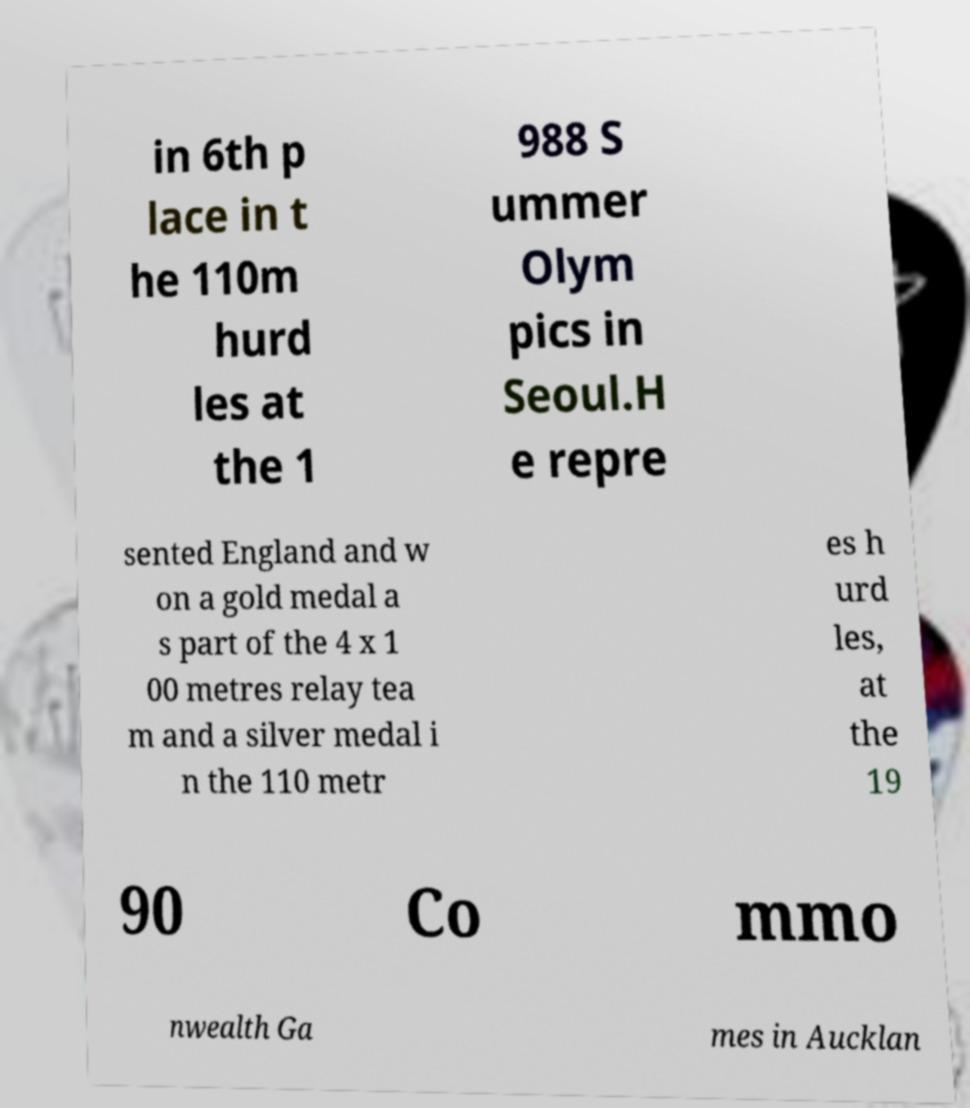Could you extract and type out the text from this image? in 6th p lace in t he 110m hurd les at the 1 988 S ummer Olym pics in Seoul.H e repre sented England and w on a gold medal a s part of the 4 x 1 00 metres relay tea m and a silver medal i n the 110 metr es h urd les, at the 19 90 Co mmo nwealth Ga mes in Aucklan 